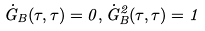<formula> <loc_0><loc_0><loc_500><loc_500>\dot { G } _ { B } ( \tau , \tau ) = 0 , \dot { G } _ { B } ^ { 2 } ( \tau , \tau ) = 1</formula> 